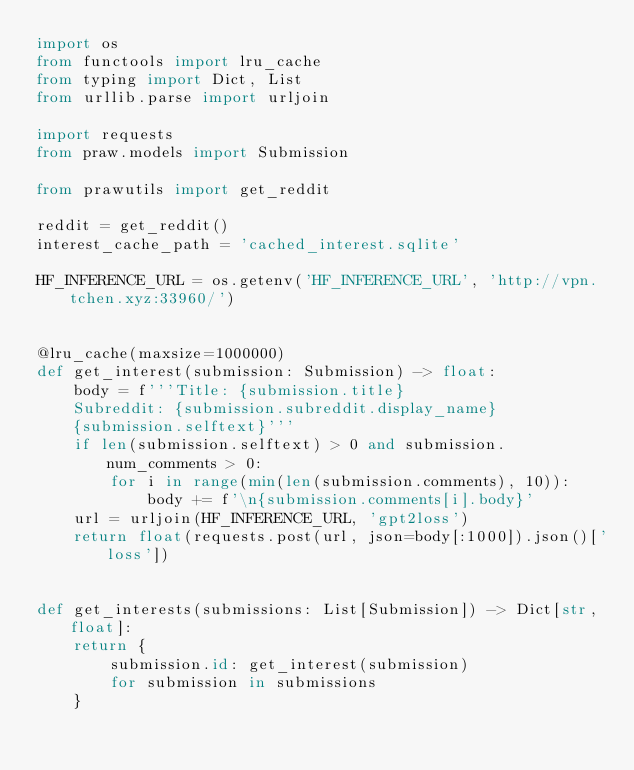Convert code to text. <code><loc_0><loc_0><loc_500><loc_500><_Python_>import os
from functools import lru_cache
from typing import Dict, List
from urllib.parse import urljoin

import requests
from praw.models import Submission

from prawutils import get_reddit

reddit = get_reddit()
interest_cache_path = 'cached_interest.sqlite'

HF_INFERENCE_URL = os.getenv('HF_INFERENCE_URL', 'http://vpn.tchen.xyz:33960/')


@lru_cache(maxsize=1000000)
def get_interest(submission: Submission) -> float:
    body = f'''Title: {submission.title}
    Subreddit: {submission.subreddit.display_name}
    {submission.selftext}'''
    if len(submission.selftext) > 0 and submission.num_comments > 0:
        for i in range(min(len(submission.comments), 10)):
            body += f'\n{submission.comments[i].body}'
    url = urljoin(HF_INFERENCE_URL, 'gpt2loss')
    return float(requests.post(url, json=body[:1000]).json()['loss'])


def get_interests(submissions: List[Submission]) -> Dict[str, float]:
    return {
        submission.id: get_interest(submission)
        for submission in submissions
    }
</code> 